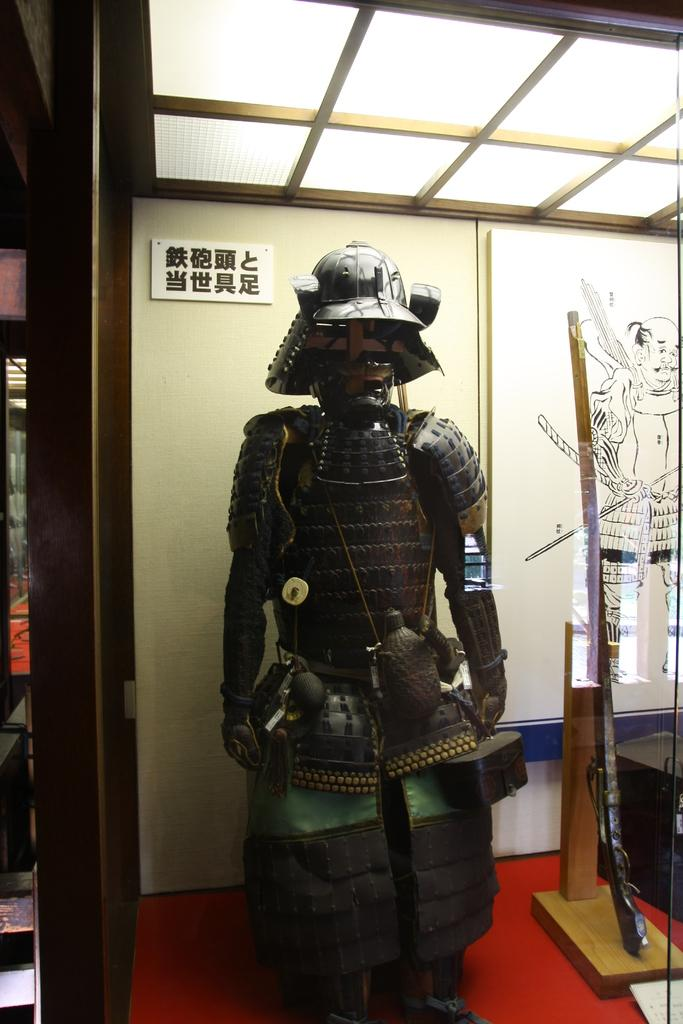What is the main subject of the image? There is a statue in the image. How many servants are attending to the statue in the image? There is no mention of servants in the image, as it only features a statue. 